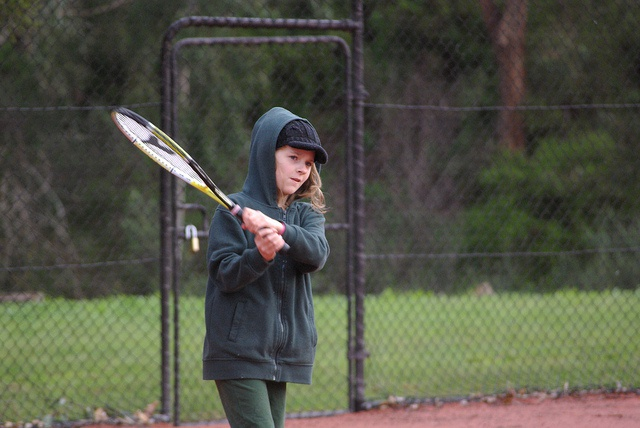Describe the objects in this image and their specific colors. I can see people in darkgreen, black, gray, and blue tones and tennis racket in darkgreen, lavender, gray, black, and darkgray tones in this image. 